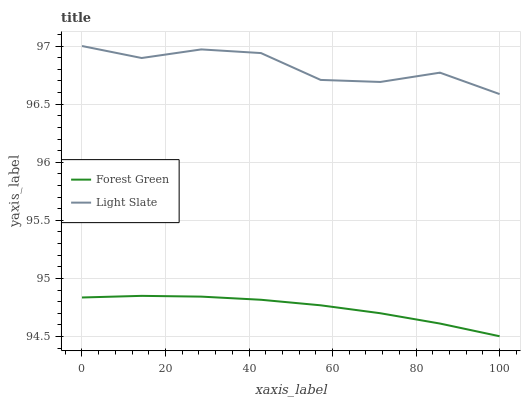Does Forest Green have the minimum area under the curve?
Answer yes or no. Yes. Does Light Slate have the maximum area under the curve?
Answer yes or no. Yes. Does Forest Green have the maximum area under the curve?
Answer yes or no. No. Is Forest Green the smoothest?
Answer yes or no. Yes. Is Light Slate the roughest?
Answer yes or no. Yes. Is Forest Green the roughest?
Answer yes or no. No. Does Forest Green have the lowest value?
Answer yes or no. Yes. Does Light Slate have the highest value?
Answer yes or no. Yes. Does Forest Green have the highest value?
Answer yes or no. No. Is Forest Green less than Light Slate?
Answer yes or no. Yes. Is Light Slate greater than Forest Green?
Answer yes or no. Yes. Does Forest Green intersect Light Slate?
Answer yes or no. No. 